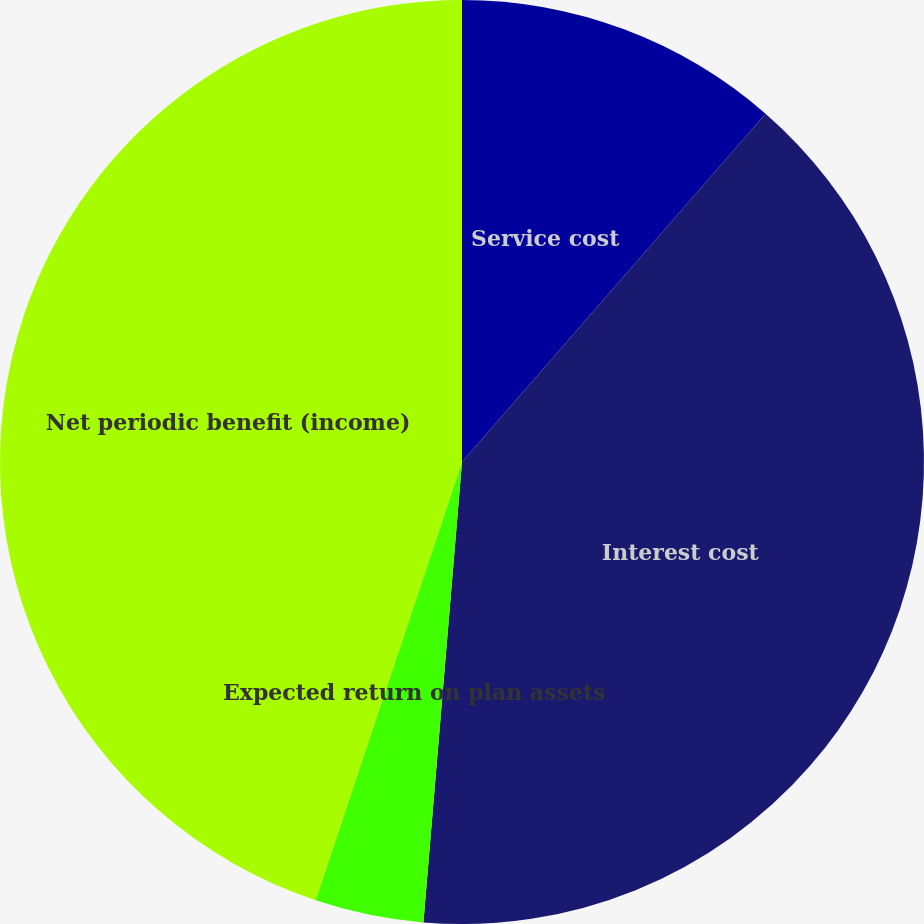<chart> <loc_0><loc_0><loc_500><loc_500><pie_chart><fcel>Service cost<fcel>Interest cost<fcel>Expected return on plan assets<fcel>Net periodic benefit (income)<nl><fcel>11.41%<fcel>39.92%<fcel>3.8%<fcel>44.87%<nl></chart> 